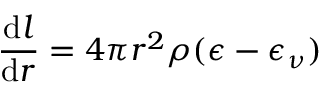Convert formula to latex. <formula><loc_0><loc_0><loc_500><loc_500>{ \frac { { d } l } { { d } r } } = 4 \pi r ^ { 2 } \rho ( \epsilon - \epsilon _ { \nu } )</formula> 